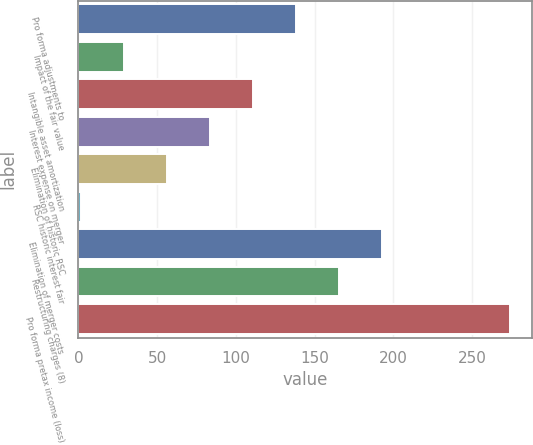<chart> <loc_0><loc_0><loc_500><loc_500><bar_chart><fcel>Pro forma adjustments to<fcel>Impact of the fair value<fcel>Intangible asset amortization<fcel>Interest expense on merger<fcel>Elimination of historic RSC<fcel>RSC historic interest fair<fcel>Elimination of merger costs<fcel>Restructuring charges (8)<fcel>Pro forma pretax income (loss)<nl><fcel>138<fcel>29.2<fcel>110.8<fcel>83.6<fcel>56.4<fcel>2<fcel>192.4<fcel>165.2<fcel>274<nl></chart> 